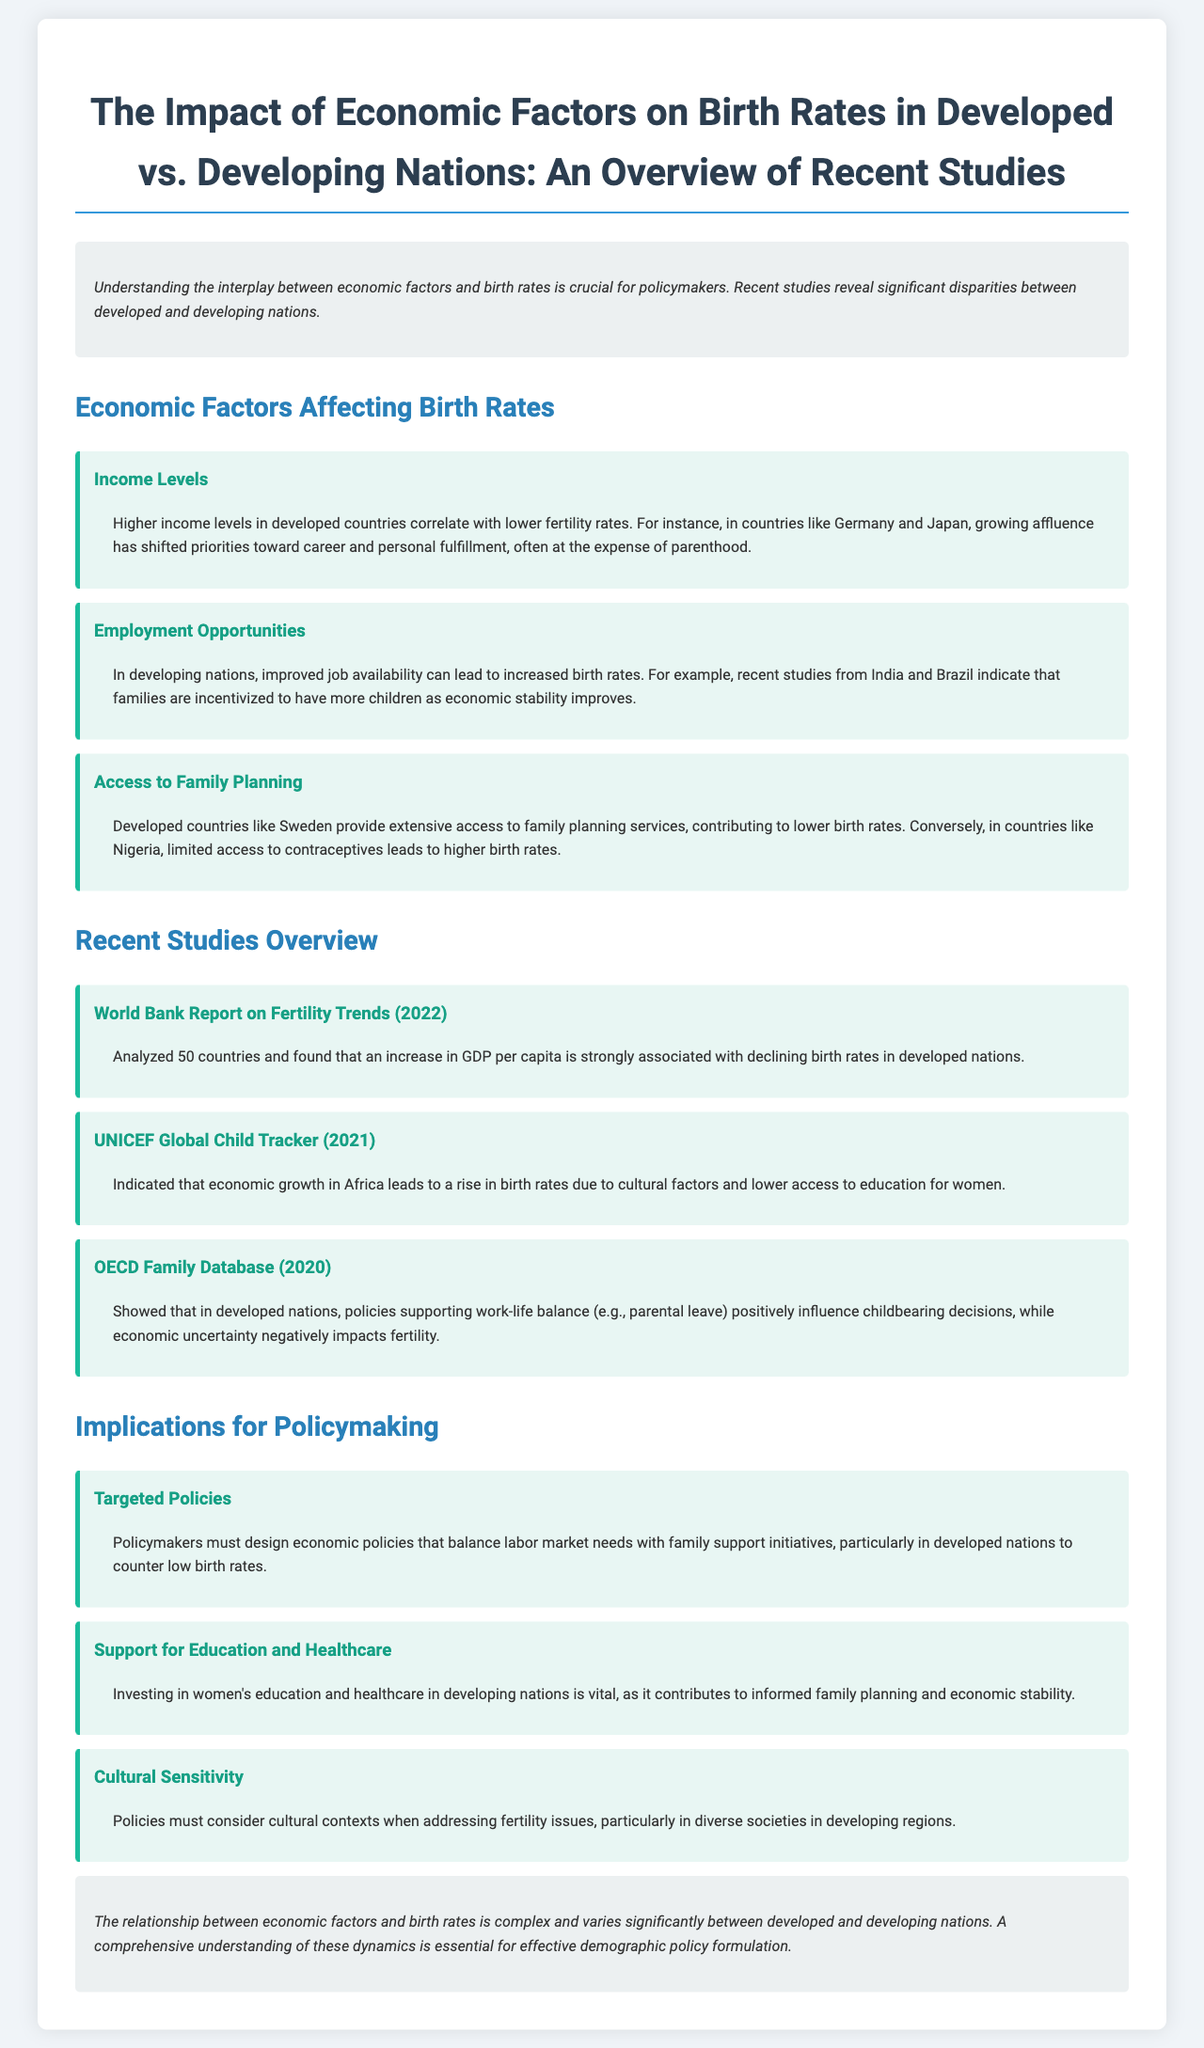What is the title of the report? The title clearly states the focus of the report which is to address the economic factors and their effects on birth rates in both developed and developing nations.
Answer: The Impact of Economic Factors on Birth Rates in Developed vs. Developing Nations: An Overview of Recent Studies Which country is mentioned as having lower fertility rates due to higher income levels? The report specifically highlights Germany and Japan as examples of developed countries where increased affluence has led to lower birth rates.
Answer: Germany and Japan What year was the OECD Family Database study published? The report mentions the OECD Family Database study as being published in 2020, along with its findings regarding work-life balance policies' effects on fertility decisions.
Answer: 2020 What does the UNICEF Global Child Tracker suggest about economic growth in Africa? The findings from the UNICEF Global Child Tracker indicate that economic growth in Africa leads to a rise in birth rates based on various cultural factors.
Answer: A rise in birth rates What should policymakers focus on to support families in developed nations? It suggests that targeted policies that balance labor market needs with family support initiatives are essential to counter low birth rates in developed nations.
Answer: Targeted policies Which factor is emphasized in the report as impacting fertility in both contexts? The report discusses access to family planning services as a significant factor affecting birth rates in both developed and developing nations.
Answer: Access to Family Planning 